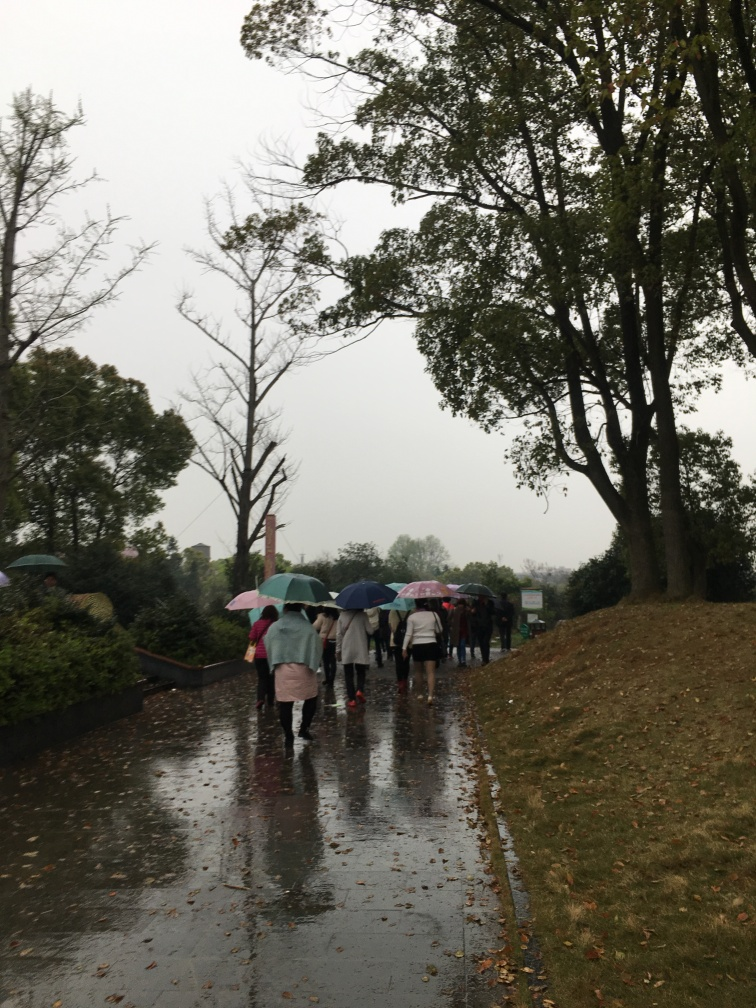Is there any lens distortion in the image? There does not appear to be noticeable lens distortion in the image. Lens distortion typically manifests as straight lines bending near the edges of a photo, but the proportions and lines within this scene, such as the edges of the pavement and the silhouette of the trees, appear natural and undistorted, in tandem with what one would expect in reality on an overcast, rainy day. 